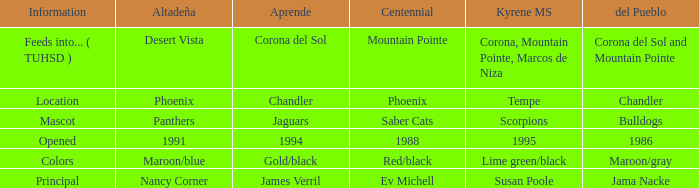Which Altadeña has a Aprende of jaguars? Panthers. 